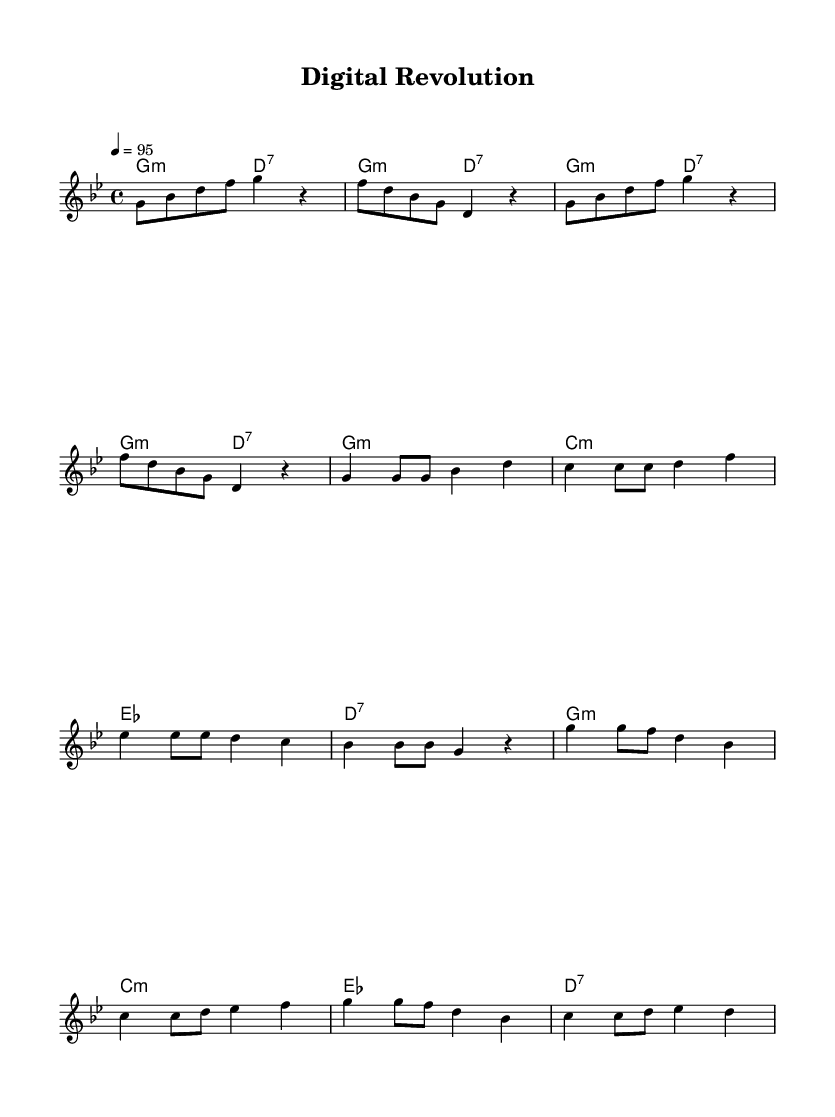What is the key signature of this music? The key signature is G minor, which contains two flats (B flat and E flat). This can be deduced from the initial part of the score notation.
Answer: G minor What is the time signature of this music? The time signature is 4/4, which indicates four beats per measure with a quarter note getting one beat. This is evident at the beginning of the score next to the key signature.
Answer: 4/4 What is the tempo marking for this piece? The tempo marking indicates a speed of 95 beats per minute, which is specified in the tempo indication at the beginning of the score.
Answer: 95 How many measures are in the verse section? The verse section consists of 4 measures, which can be identified by counting the groups of 4 beats as notated in the music.
Answer: 4 What type of chord is used in the first measure? The first measure contains a G minor chord, which is indicated in the chord symbols above the staff. This is derived from the chord mode section of the score.
Answer: G minor What is the rhythmic pattern of the chorus section? The chorus exhibits a rhythmic pattern that alternates between quarter notes and eighth notes in a consistent way, allowing for a dynamic flow typical of upbeat hip-hop tracks. This is established through the note durations seen in the chorus section.
Answer: Alternating quarter and eighth notes How does the structure of this piece reflect typical characteristics of Rap music? The piece has a repetitive structure with a clear verse and chorus pattern, common in Rap music, which aids in enhancing memorable hooks and lyrical flow. This can be observed in the repetition of melodic phrases and the layout of the score.
Answer: Repetitive verse-chorus structure 